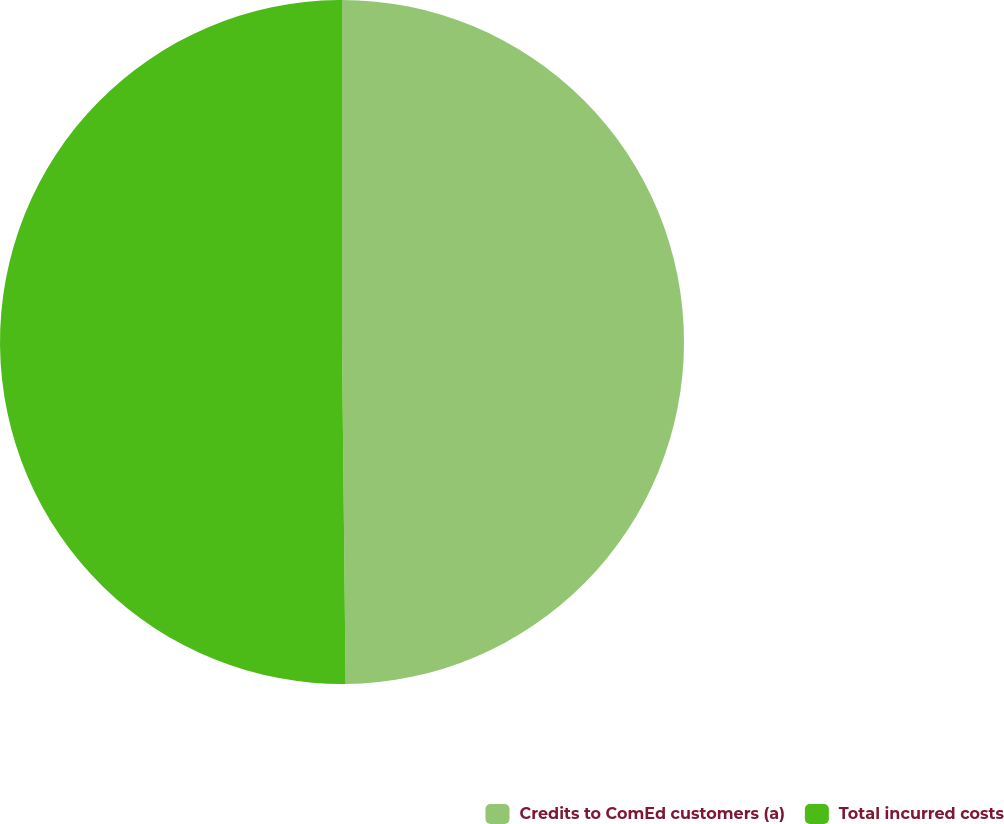<chart> <loc_0><loc_0><loc_500><loc_500><pie_chart><fcel>Credits to ComEd customers (a)<fcel>Total incurred costs<nl><fcel>49.83%<fcel>50.17%<nl></chart> 